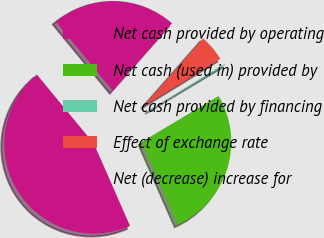Convert chart to OTSL. <chart><loc_0><loc_0><loc_500><loc_500><pie_chart><fcel>Net cash provided by operating<fcel>Net cash (used in) provided by<fcel>Net cash provided by financing<fcel>Effect of exchange rate<fcel>Net (decrease) increase for<nl><fcel>45.61%<fcel>26.98%<fcel>0.21%<fcel>4.75%<fcel>22.44%<nl></chart> 